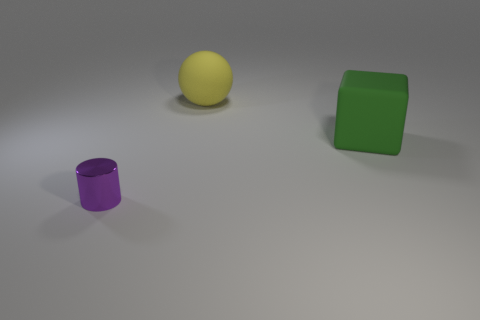Subtract all cyan cylinders. Subtract all yellow blocks. How many cylinders are left? 1 Add 2 tiny purple metal balls. How many objects exist? 5 Subtract all cubes. How many objects are left? 2 Subtract all big green rubber things. Subtract all cubes. How many objects are left? 1 Add 2 rubber cubes. How many rubber cubes are left? 3 Add 1 purple objects. How many purple objects exist? 2 Subtract 0 cyan balls. How many objects are left? 3 